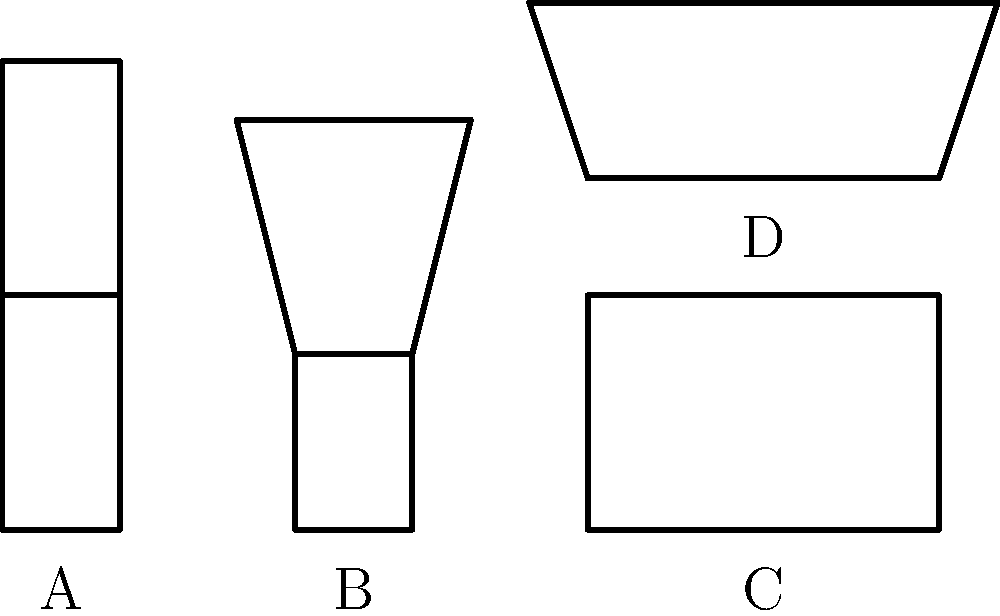As a movie producer seeking authentic props for a period film set in the 1960s, which of the furniture sketches (A, B, C, or D) would be most appropriate for your production? To answer this question, we need to analyze the characteristics of each furniture sketch and compare them to typical 1960s furniture styles:

1. Sketch A: This chair has a straight, rectangular back and seat. It represents a more traditional or earlier style, likely pre-1960s.

2. Sketch B: This chair has a curved, organic shape with a wider top on the backrest. This design is characteristic of mid-century modern furniture, which was popular in the 1950s and 1960s.

3. Sketch C: This table has a rectangular shape with straight lines, representing a more traditional or earlier style.

4. Sketch D: This table has a trapezoidal shape with angled legs, which is typical of mid-century modern design popular in the 1960s.

Given that the film is set in the 1960s, we should focus on furniture that embodies the mid-century modern style. This style is characterized by clean lines, organic shapes, and a mix of traditional and non-traditional materials.

Among the sketches provided, B (the chair) and D (the table) best represent the mid-century modern style that was popular in the 1960s. Their curved lines and distinctive shapes are emblematic of this period's design aesthetic.

Therefore, the most appropriate choices for a 1960s period film would be sketches B and D.
Answer: B and D 